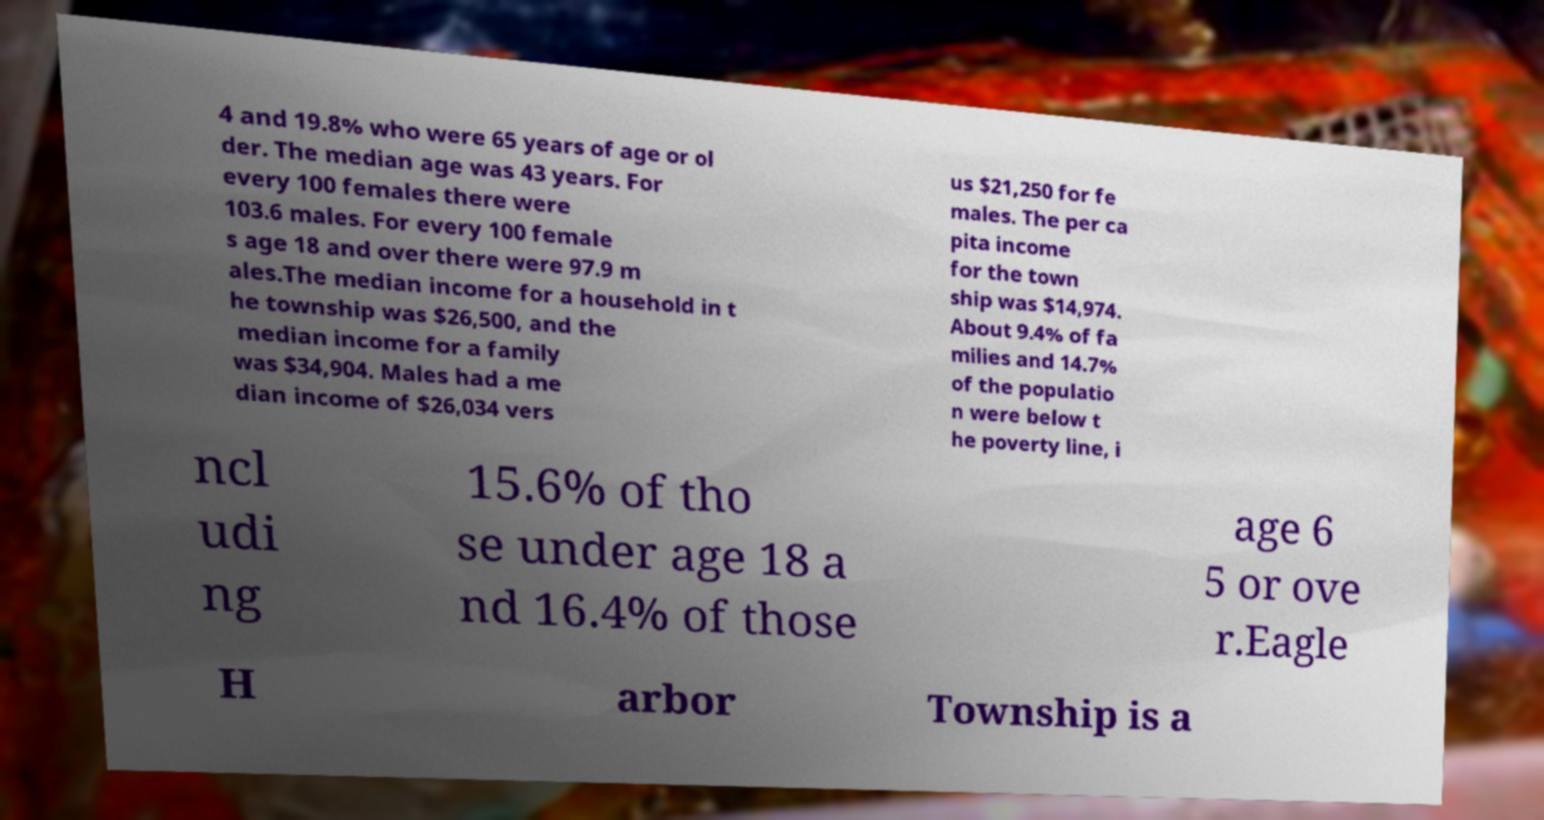Could you assist in decoding the text presented in this image and type it out clearly? 4 and 19.8% who were 65 years of age or ol der. The median age was 43 years. For every 100 females there were 103.6 males. For every 100 female s age 18 and over there were 97.9 m ales.The median income for a household in t he township was $26,500, and the median income for a family was $34,904. Males had a me dian income of $26,034 vers us $21,250 for fe males. The per ca pita income for the town ship was $14,974. About 9.4% of fa milies and 14.7% of the populatio n were below t he poverty line, i ncl udi ng 15.6% of tho se under age 18 a nd 16.4% of those age 6 5 or ove r.Eagle H arbor Township is a 